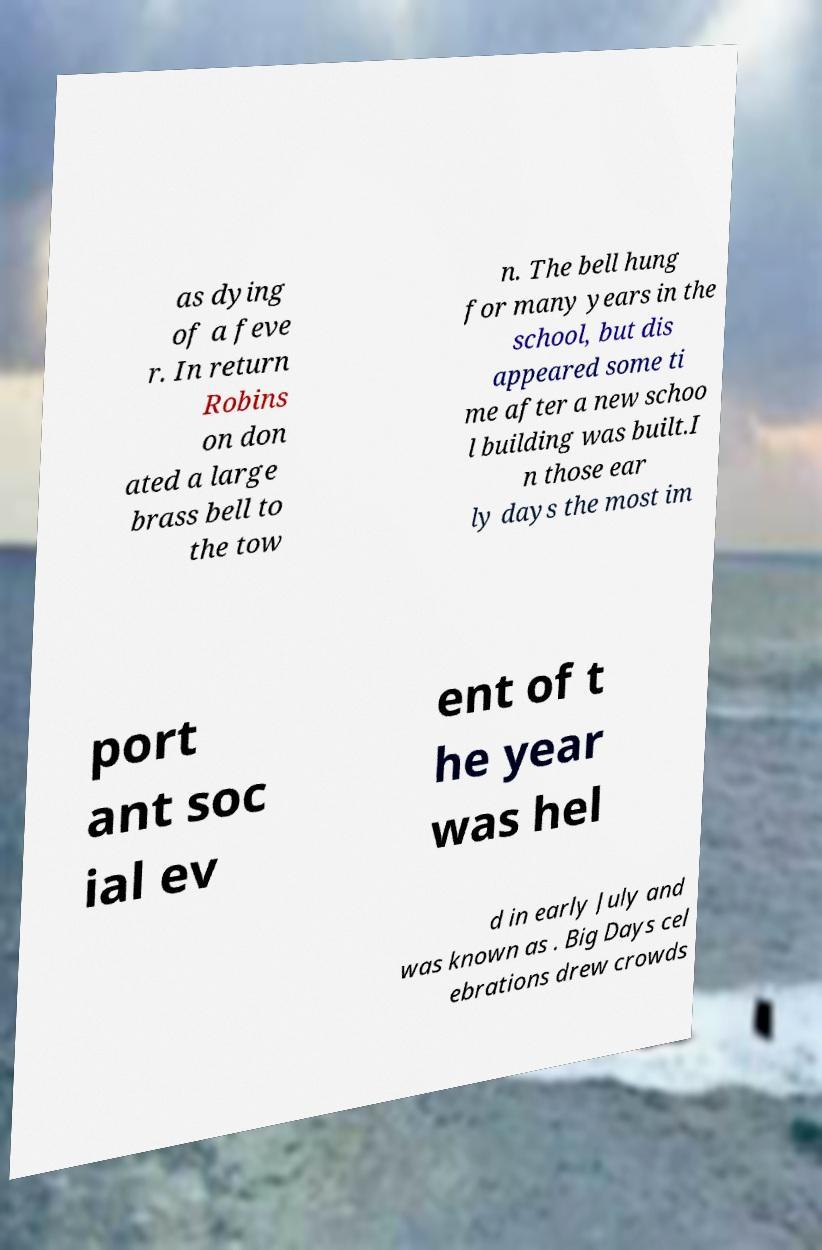Please read and relay the text visible in this image. What does it say? as dying of a feve r. In return Robins on don ated a large brass bell to the tow n. The bell hung for many years in the school, but dis appeared some ti me after a new schoo l building was built.I n those ear ly days the most im port ant soc ial ev ent of t he year was hel d in early July and was known as . Big Days cel ebrations drew crowds 